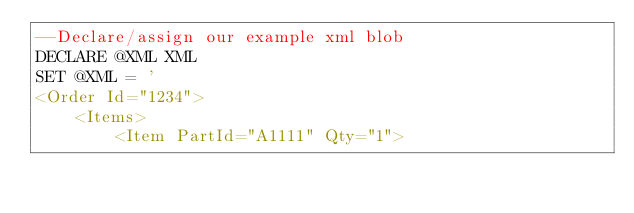Convert code to text. <code><loc_0><loc_0><loc_500><loc_500><_SQL_>--Declare/assign our example xml blob
DECLARE @XML XML
SET @XML = '
<Order Id="1234">
    <Items>
        <Item PartId="A1111" Qty="1"></code> 